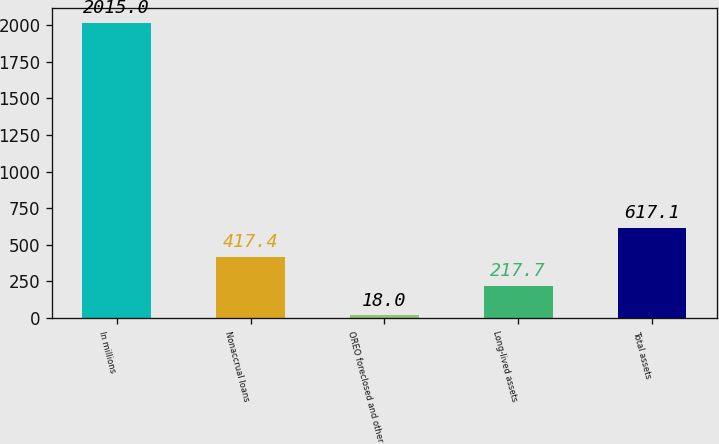Convert chart to OTSL. <chart><loc_0><loc_0><loc_500><loc_500><bar_chart><fcel>In millions<fcel>Nonaccrual loans<fcel>OREO foreclosed and other<fcel>Long-lived assets<fcel>Total assets<nl><fcel>2015<fcel>417.4<fcel>18<fcel>217.7<fcel>617.1<nl></chart> 